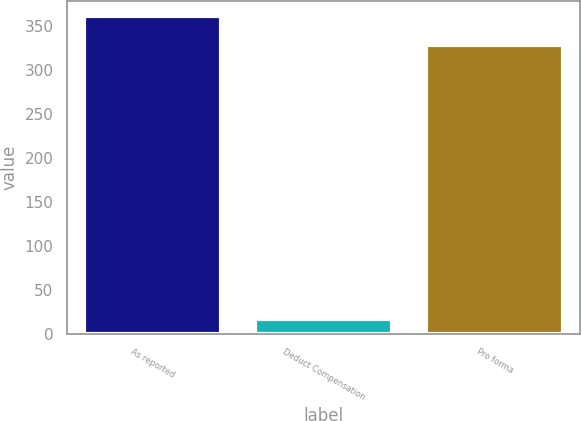Convert chart. <chart><loc_0><loc_0><loc_500><loc_500><bar_chart><fcel>As reported<fcel>Deduct Compensation<fcel>Pro forma<nl><fcel>361.35<fcel>17.1<fcel>328.5<nl></chart> 